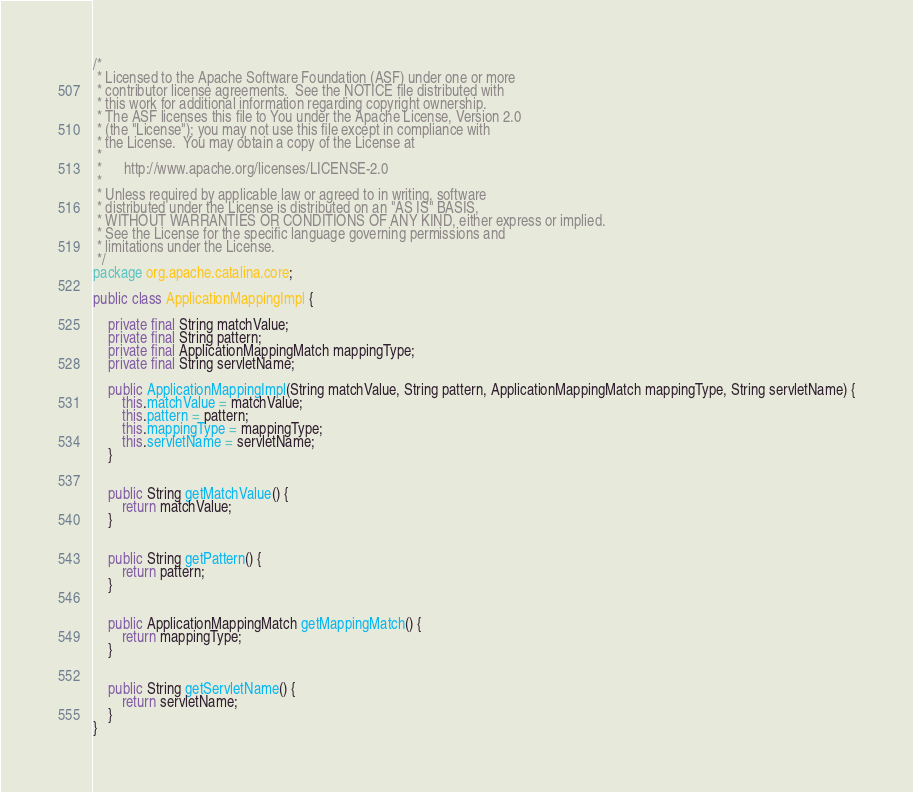Convert code to text. <code><loc_0><loc_0><loc_500><loc_500><_Java_>/*
 * Licensed to the Apache Software Foundation (ASF) under one or more
 * contributor license agreements.  See the NOTICE file distributed with
 * this work for additional information regarding copyright ownership.
 * The ASF licenses this file to You under the Apache License, Version 2.0
 * (the "License"); you may not use this file except in compliance with
 * the License.  You may obtain a copy of the License at
 *
 *      http://www.apache.org/licenses/LICENSE-2.0
 *
 * Unless required by applicable law or agreed to in writing, software
 * distributed under the License is distributed on an "AS IS" BASIS,
 * WITHOUT WARRANTIES OR CONDITIONS OF ANY KIND, either express or implied.
 * See the License for the specific language governing permissions and
 * limitations under the License.
 */
package org.apache.catalina.core;

public class ApplicationMappingImpl {

    private final String matchValue;
    private final String pattern;
    private final ApplicationMappingMatch mappingType;
    private final String servletName;

    public ApplicationMappingImpl(String matchValue, String pattern, ApplicationMappingMatch mappingType, String servletName) {
        this.matchValue = matchValue;
        this.pattern = pattern;
        this.mappingType = mappingType;
        this.servletName = servletName;
    }


    public String getMatchValue() {
        return matchValue;
    }


    public String getPattern() {
        return pattern;
    }


    public ApplicationMappingMatch getMappingMatch() {
        return mappingType;
    }


    public String getServletName() {
        return servletName;
    }
}
</code> 